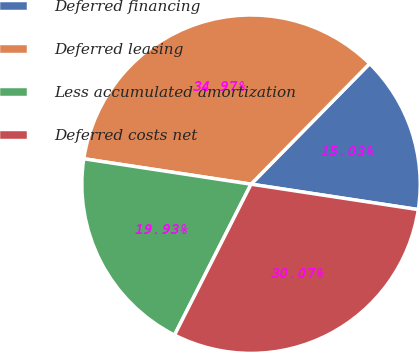Convert chart. <chart><loc_0><loc_0><loc_500><loc_500><pie_chart><fcel>Deferred financing<fcel>Deferred leasing<fcel>Less accumulated amortization<fcel>Deferred costs net<nl><fcel>15.03%<fcel>34.97%<fcel>19.93%<fcel>30.07%<nl></chart> 